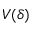<formula> <loc_0><loc_0><loc_500><loc_500>V ( \delta )</formula> 